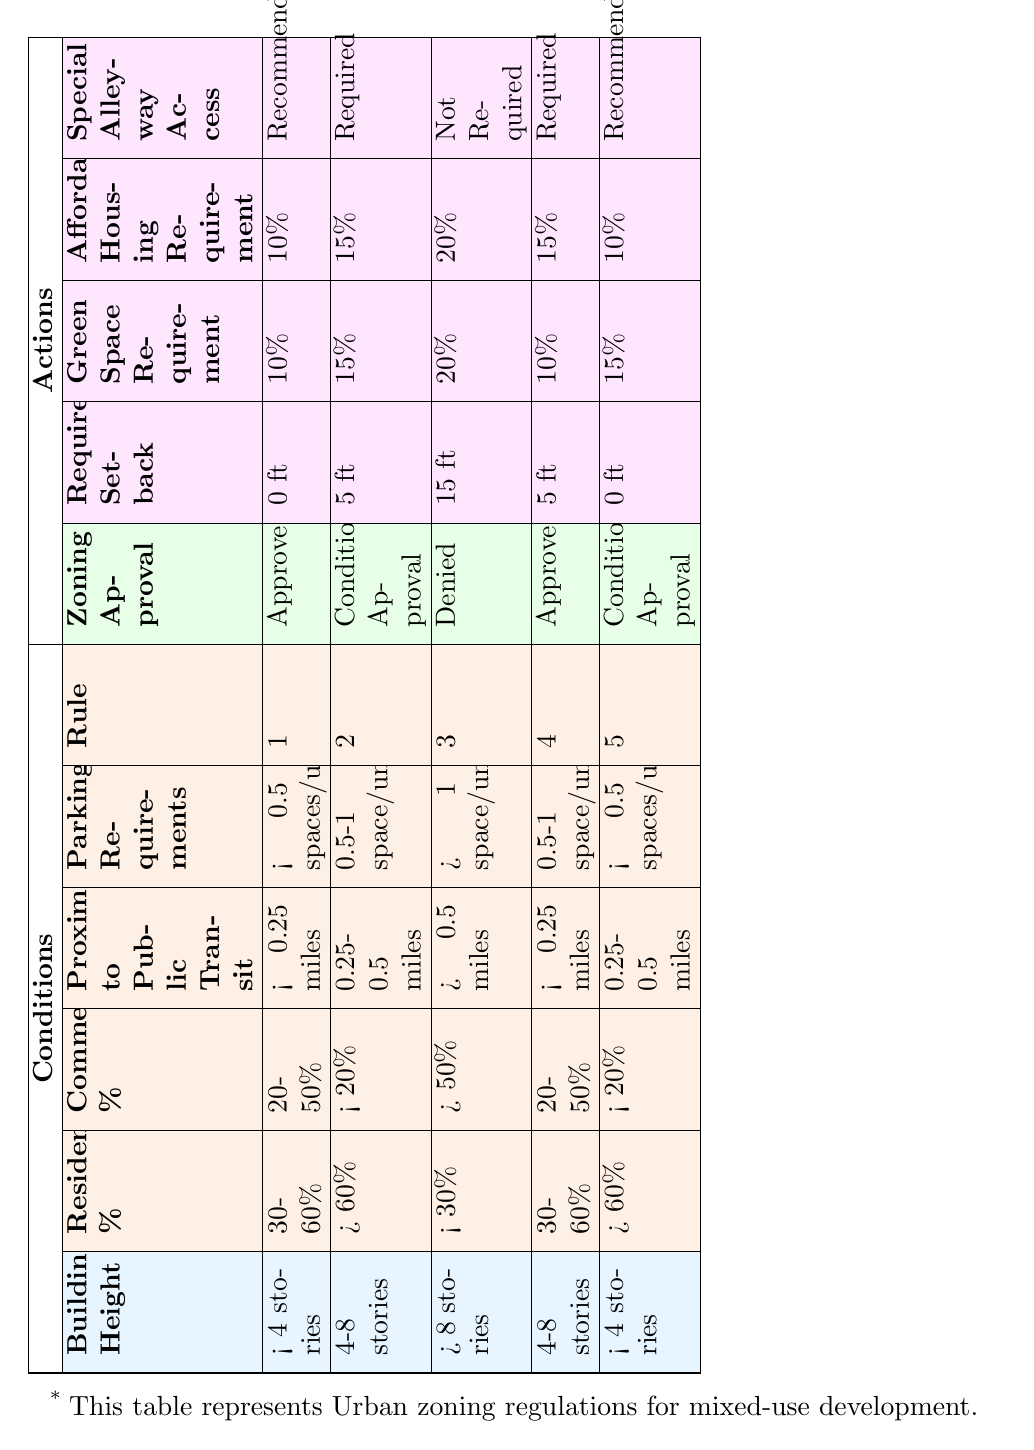What is the zoning approval for buildings that are 4-8 stories with a residential percentage of 30-60% and a commercial percentage of 20-50%? In the table, we look for the row where the building height is "4-8 stories," the residential percentage is "30-60%," and the commercial percentage is "20-50%." There are two rows that match these criteria, both of which indicate "Approved" for zoning approval.
Answer: Approved What is the required setback for buildings that are less than 4 stories and have a residential percentage greater than 60%? In the table, we check for the row where the building height is "< 4 stories" and the residential percentage is "> 60%." We find one matching row, which specifies a required setback of "0 ft."
Answer: 0 ft Is a green space requirement of 15% possible for buildings over 8 stories with a commercial percentage over 50%? Checking the row with "> 8 stories" and "> 50%" for commercial percentage, we see it indicates a green space requirement of "20%," not 15%. Therefore, it is not possible.
Answer: No What is the average green space requirement for buildings that have a height less than 4 stories? There are two entries with building height "< 4 stories," which require 10% and 15% green space respectively. We calculate the average: (10% + 15%) / 2 = 12.5%.
Answer: 12.5% How many zoning approvals are classified as Conditional Approval in the table? By examining the "Zoning Approval" column, we find two entries listed as "Conditional Approval," indicating they meet specific conditions for approval.
Answer: 2 What defines whether special alleyway access is required for mixed-use developments with a specific zoning outcome? We observe the rows with different zoning approvals and identify the requirements for special alleyway access. "Required" is mentioned in two cases with "Conditional Approval" and one case with "Approved," suggesting it depends on meeting additional conditions.
Answer: It varies based on zoning approval 